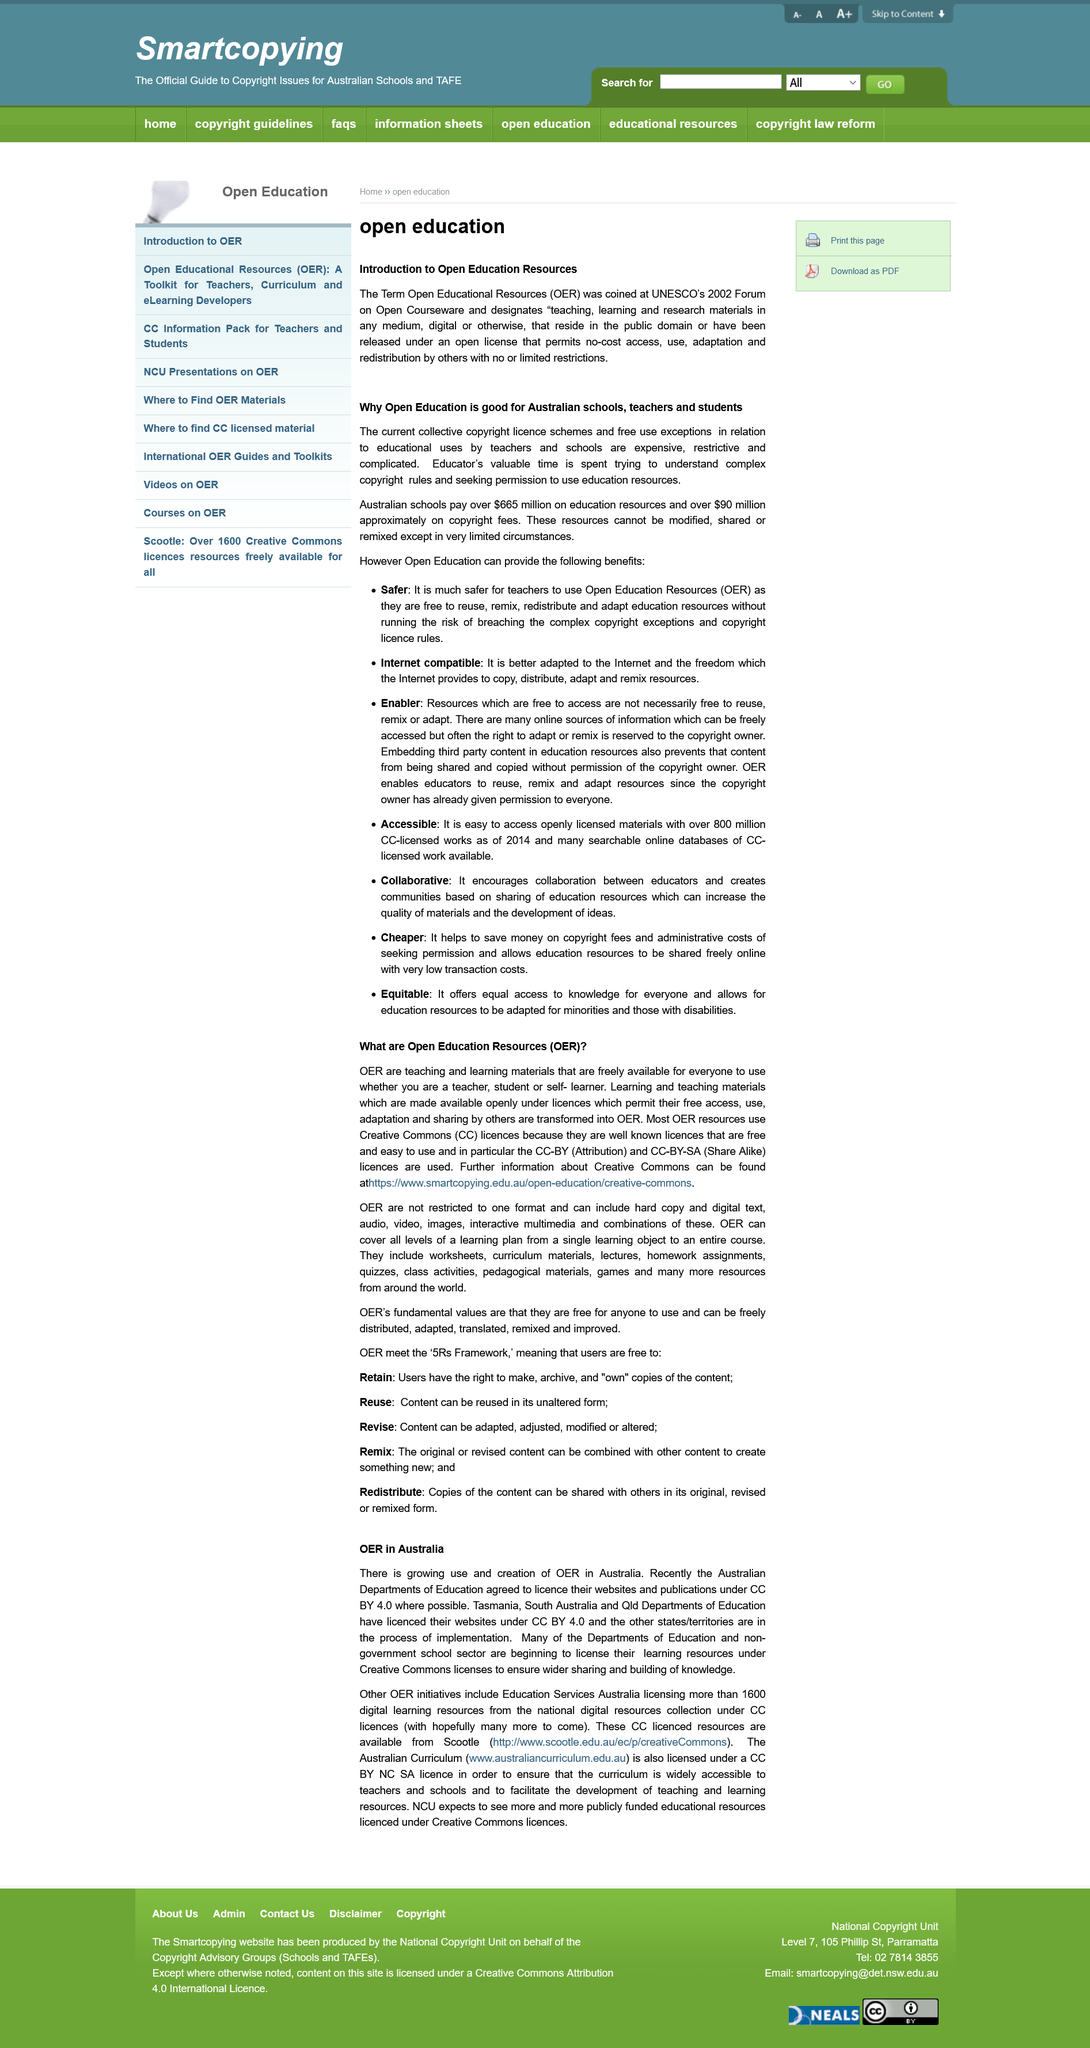Specify some key components in this picture. Open Education Resources (OER) are teaching and learning materials that are freely available for everyone to use and distribute, without the need for permission or payment, in accordance with open licenses. The licensing agreement for the article is CC BY 4.0 The article is discussing the continent of Australia. The source "Further information about Creative Commons can be found at <https://www.smartcopying.edu.au/open-education/creative-commons/>." is a reliable source for information about Creative Commons. OERs are accessible to teachers, students, and self-learners alike. 